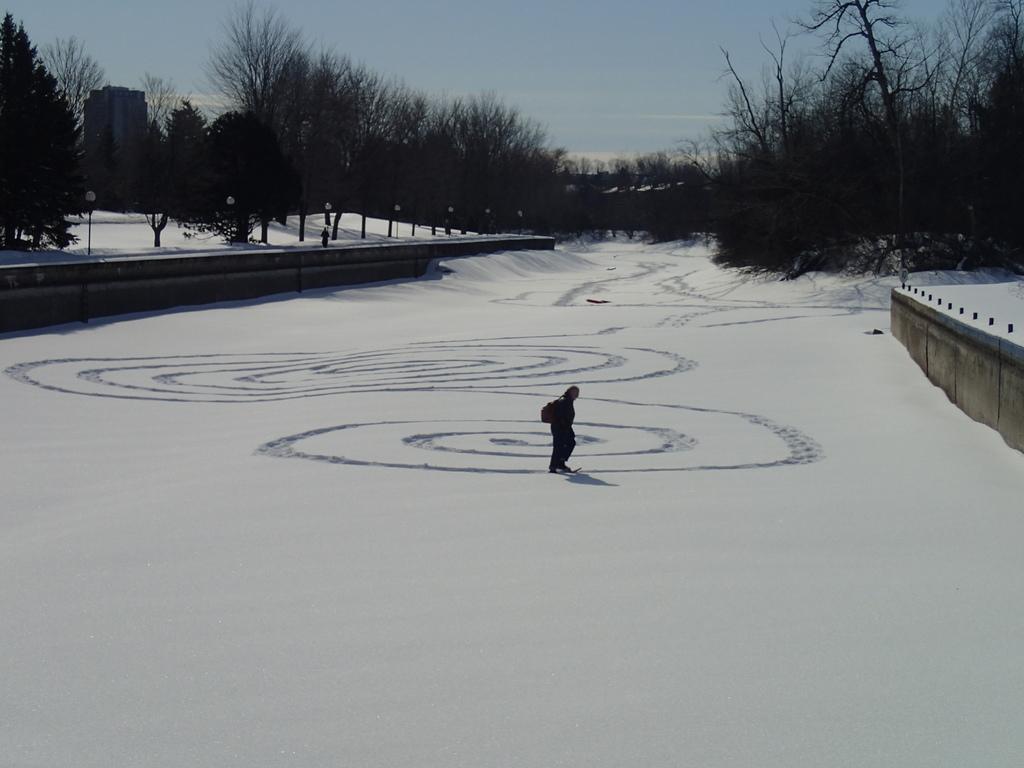In one or two sentences, can you explain what this image depicts? In the middle of the image, there is a person walking on a line which is on the snow surface. On the right side, there is a wall. In the background, there are trees, a building and there is a blue sky. 